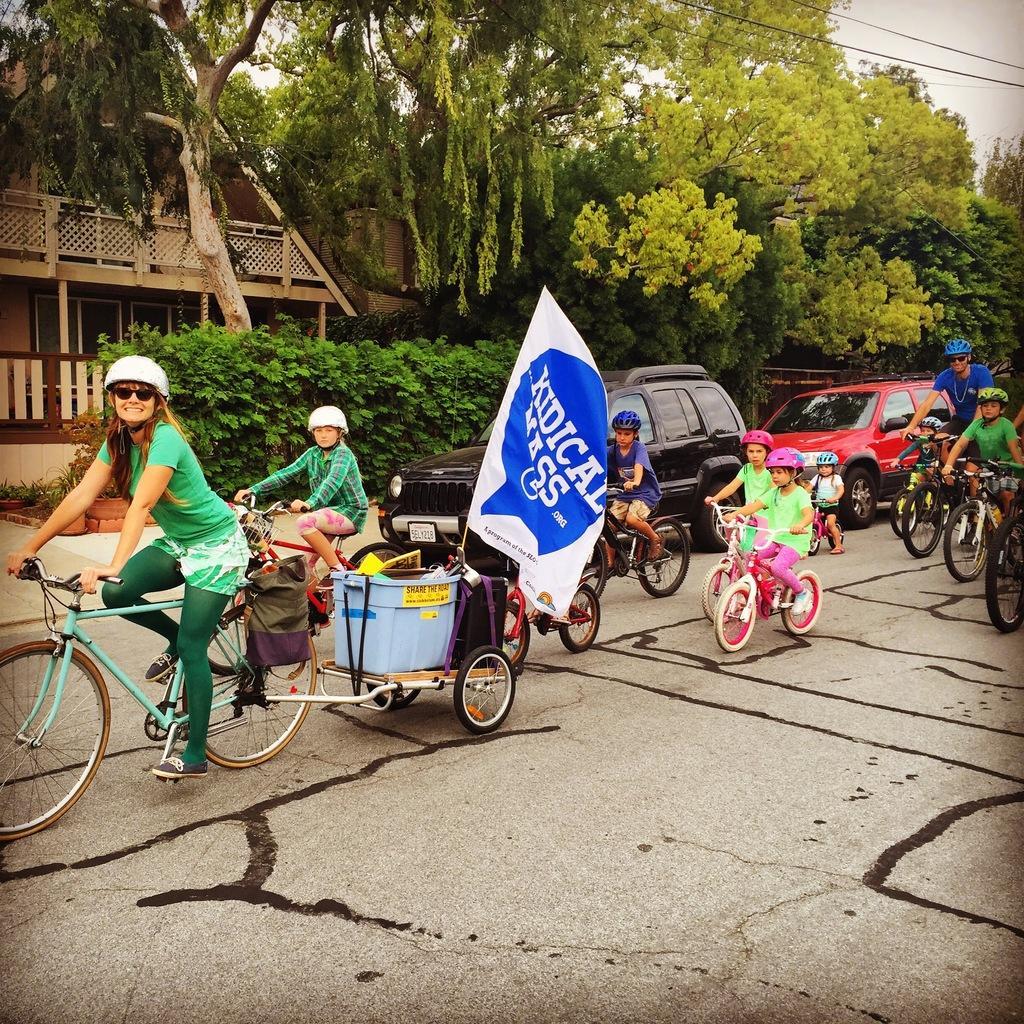Describe this image in one or two sentences. There is a woman riding a bicycle and wearing a helmet. Behind her there are some children riding bicycles with a flag behind them. In the background there are some plants, cars, trees and buildings here. 